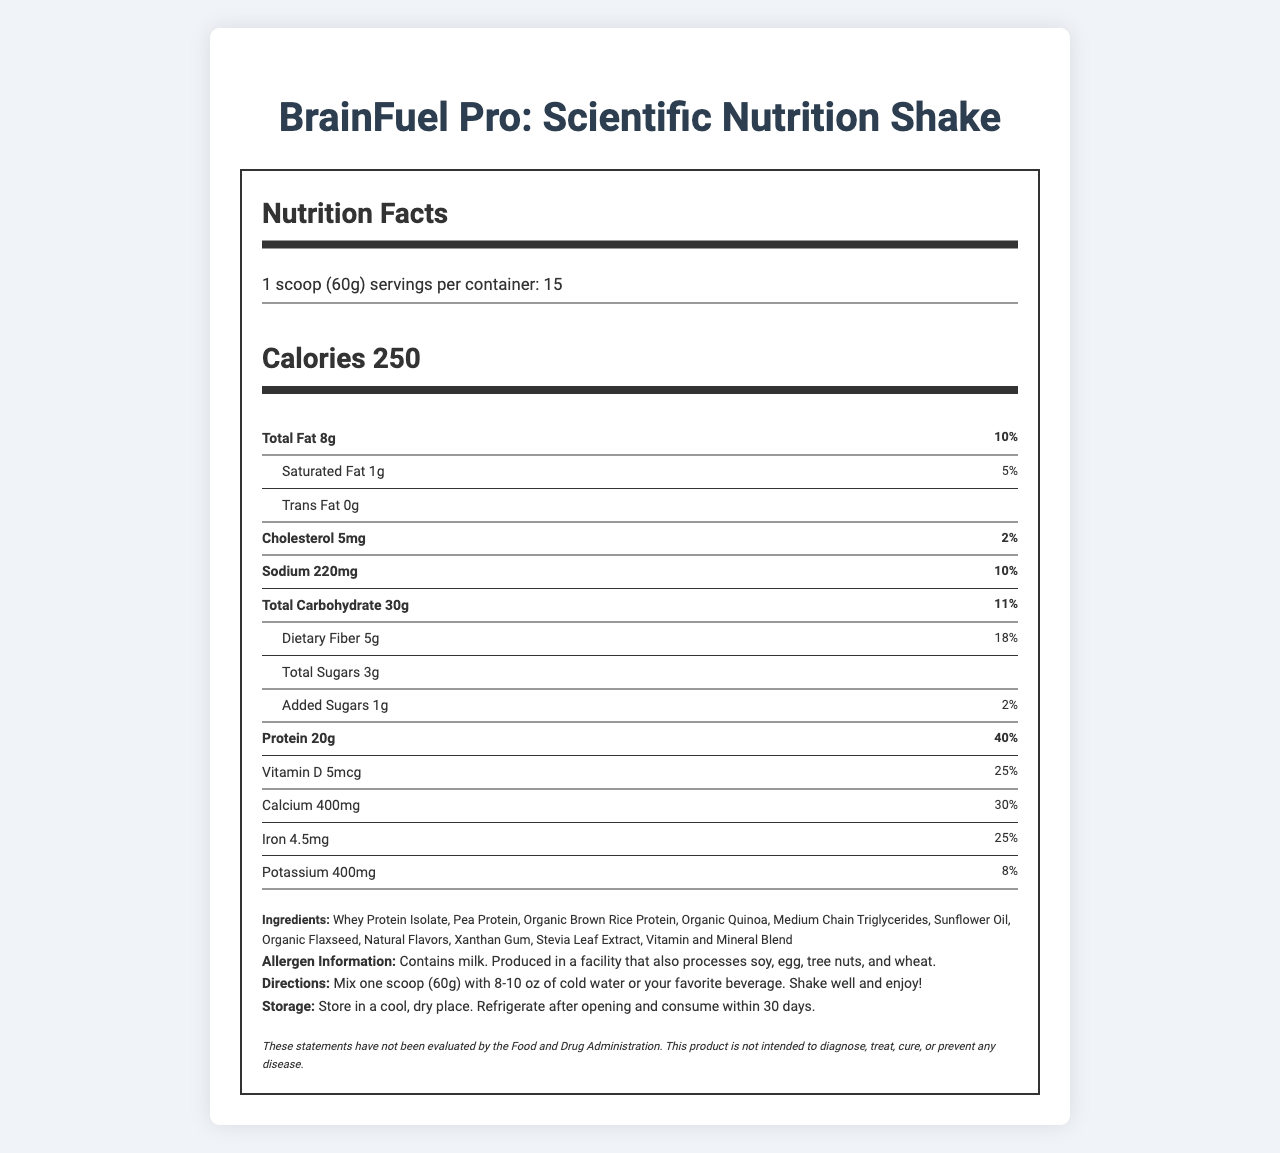what is the serving size? The serving size is specified at the beginning of the nutrition facts label: "1 scoop (60g)".
Answer: 1 scoop (60g) how many calories are there per serving? The document clearly states that there are 250 calories per serving.
Answer: 250 how many grams of total fat are in one serving? Under the nutrition facts, it's noted that the total fat amount per serving is 8g.
Answer: 8g what is the daily value percentage of dietary fiber? The daily value percentage for dietary fiber is given directly in the nutrition facts: "Dietary Fiber 5g, 18%".
Answer: 18% What is the amount of Vitamin C per serving? The amount of Vitamin C per serving is specified in the nutrients section: "Vitamin C 45mg".
Answer: 45mg Which ingredient is listed first? A. Organic Brown Rice Protein B. Whey Protein Isolate C. Organic Quinoa The ingredients list starts with "Whey Protein Isolate", making it the first ingredient listed.
Answer: B What is the daily value percentage for calcium? A. 20% B. 25% C. 30% D. 35% The daily value percentage for calcium is listed as 30%.
Answer: C Is this product suitable for someone with a milk allergy? The allergen information states that the product contains milk. "Allergen Information: Contains milk."
Answer: No Summarize the main nutritional components of this product. The summary covers the main nutritional contents and targeted audience of the product, including macro-nutrients and key vitamins and minerals.
Answer: This product, "BrainFuel Pro: Scientific Nutrition Shake", provides a balanced mix of nutrients designed for busy scientists. Each serving (60g) contains 250 calories, 8g of total fat, 30g of carbohydrates (with 5g dietary fiber and 3g total sugars), and 20g of protein. It is fortified with various vitamins and minerals, including significant amounts of vitamins A, C, D, and key B vitamins, as well as minerals like calcium, iron, and potassium. How many servings are there in a container? The document states that there are 15 servings per container.
Answer: 15 What are the directions for preparing the shake? The directions clearly state to mix one scoop with 8-10 oz of cold water or a preferred beverage, shake well, and then consume.
Answer: Mix one scoop (60g) with 8-10 oz of cold water or your favorite beverage. Shake well and enjoy! What is the main purpose of this disclaimer? This informs the consumer that the product's claims haven't been verified by the FDA and clarifies the product's intended use.
Answer: The disclaimer indicates that the statements have not been evaluated by the FDA and that the product is not intended to diagnose, treat, cure, or prevent any disease. What is the amount of added sugars per serving? The document specifies the amount of added sugars is 1g.
Answer: 1g Which of the following vitamins is present in the highest daily value? A. Vitamin D B. Vitamin C C. Vitamin B12 D. Thiamin The daily value percentages for vitamins listed are: Vitamin D 25%, Vitamin C 50%, Vitamin B12 50%, Thiamin 50%. Therefore, Vitamin C presents the highest daily value percentage (50%).
Answer: B Can we determine the price of the shake from the document? The document does not provide any pricing information.
Answer: Not enough information what is the total carbohydrate content? The total carbohydrate amount per serving is specified as 30g.
Answer: 30g 